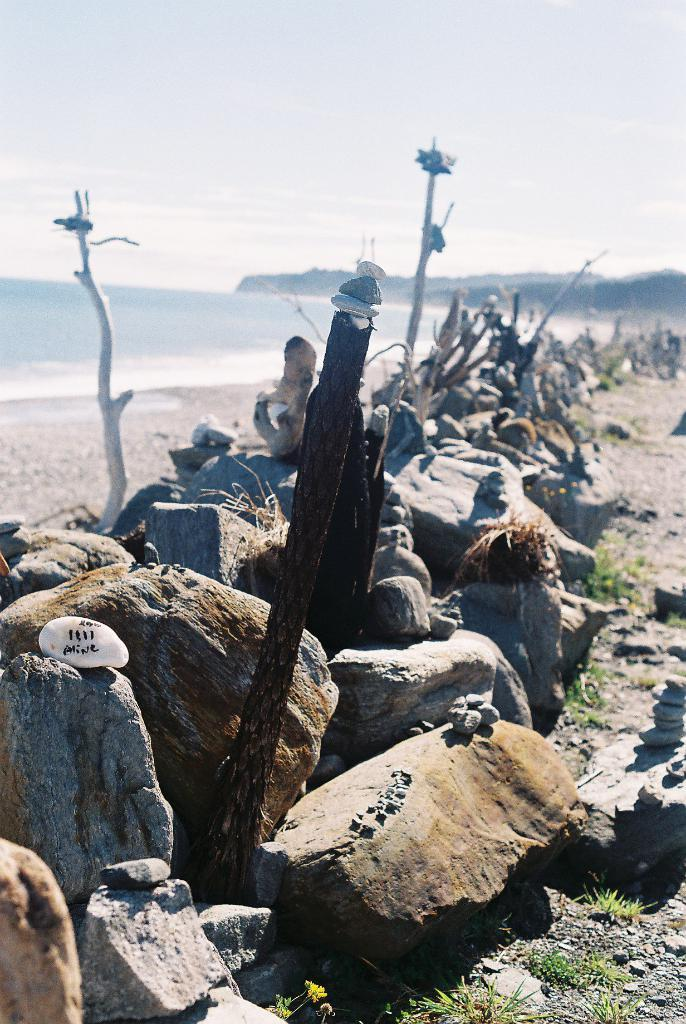What is located in the center of the image? There are stones in the center of the image. What can be seen on the left side of the image? There is water on the left side of the image. What type of natural formation is visible in the background of the image? There are mountains in the background of the image. How would you describe the sky in the image? The sky is cloudy. How many firemen are present in the image? There are no firemen present in the image. What type of mountain is depicted in the image? The image does not depict a specific type of mountain; it simply shows mountains in the background. 